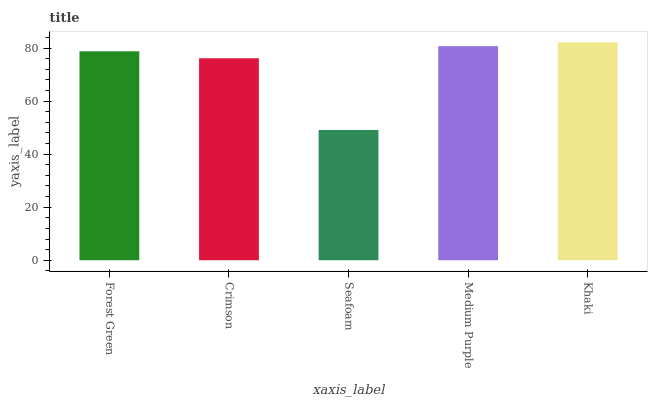Is Seafoam the minimum?
Answer yes or no. Yes. Is Khaki the maximum?
Answer yes or no. Yes. Is Crimson the minimum?
Answer yes or no. No. Is Crimson the maximum?
Answer yes or no. No. Is Forest Green greater than Crimson?
Answer yes or no. Yes. Is Crimson less than Forest Green?
Answer yes or no. Yes. Is Crimson greater than Forest Green?
Answer yes or no. No. Is Forest Green less than Crimson?
Answer yes or no. No. Is Forest Green the high median?
Answer yes or no. Yes. Is Forest Green the low median?
Answer yes or no. Yes. Is Medium Purple the high median?
Answer yes or no. No. Is Khaki the low median?
Answer yes or no. No. 